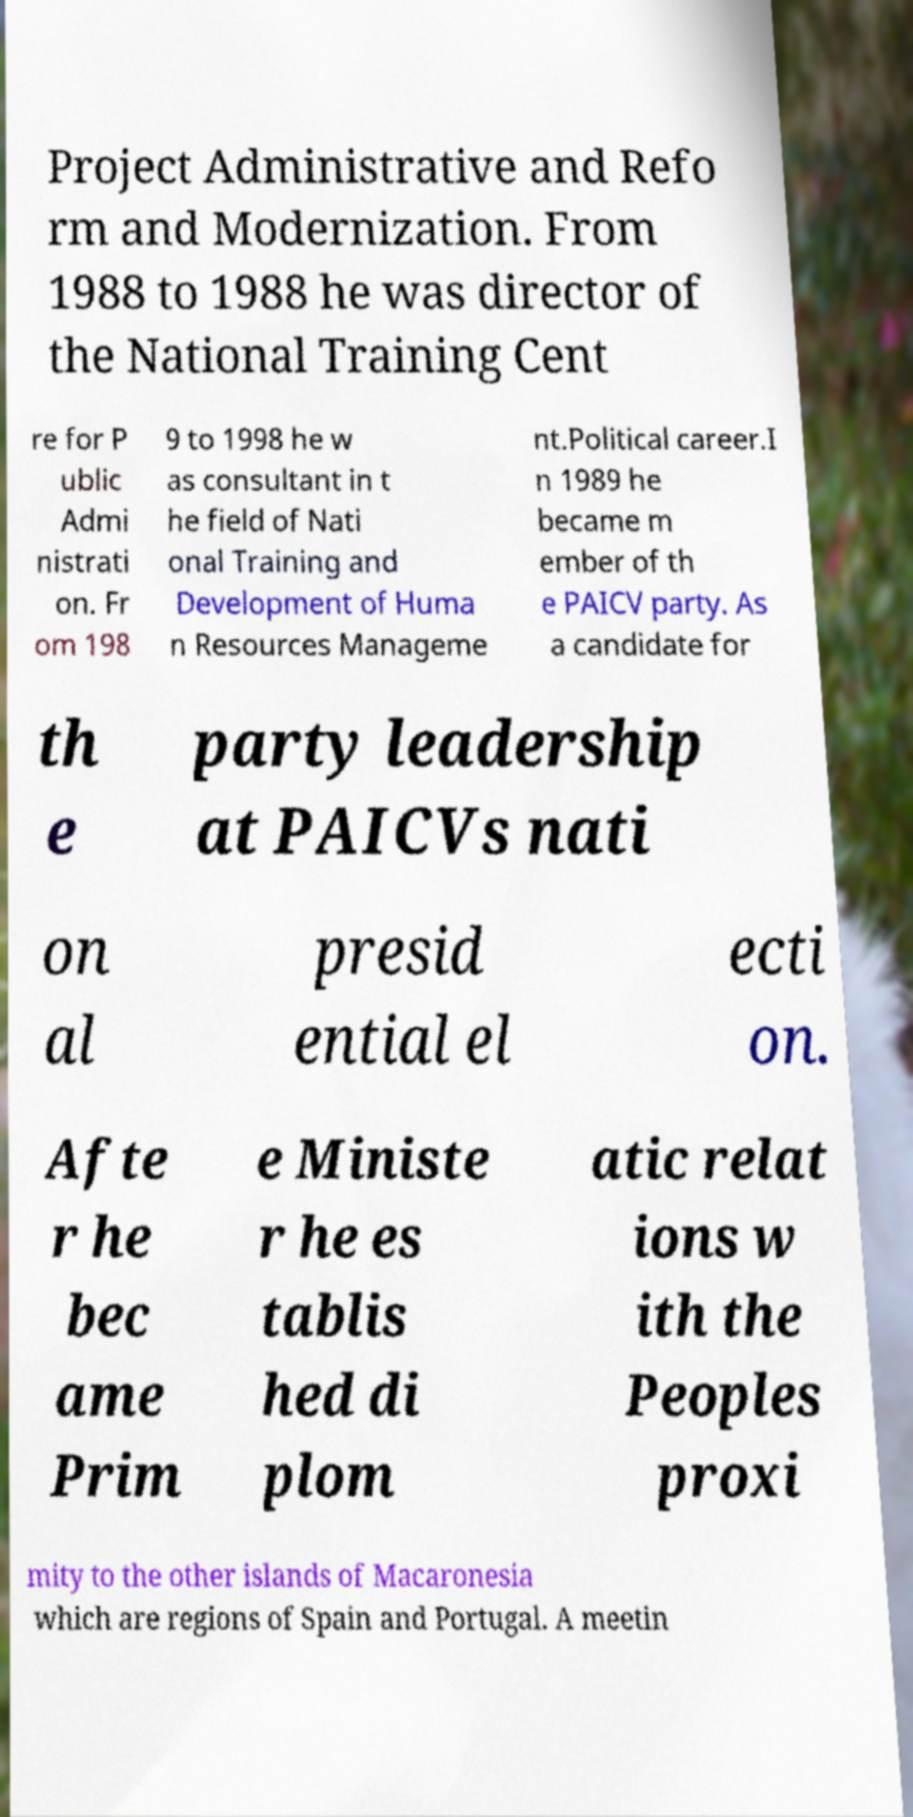Please read and relay the text visible in this image. What does it say? Project Administrative and Refo rm and Modernization. From 1988 to 1988 he was director of the National Training Cent re for P ublic Admi nistrati on. Fr om 198 9 to 1998 he w as consultant in t he field of Nati onal Training and Development of Huma n Resources Manageme nt.Political career.I n 1989 he became m ember of th e PAICV party. As a candidate for th e party leadership at PAICVs nati on al presid ential el ecti on. Afte r he bec ame Prim e Ministe r he es tablis hed di plom atic relat ions w ith the Peoples proxi mity to the other islands of Macaronesia which are regions of Spain and Portugal. A meetin 